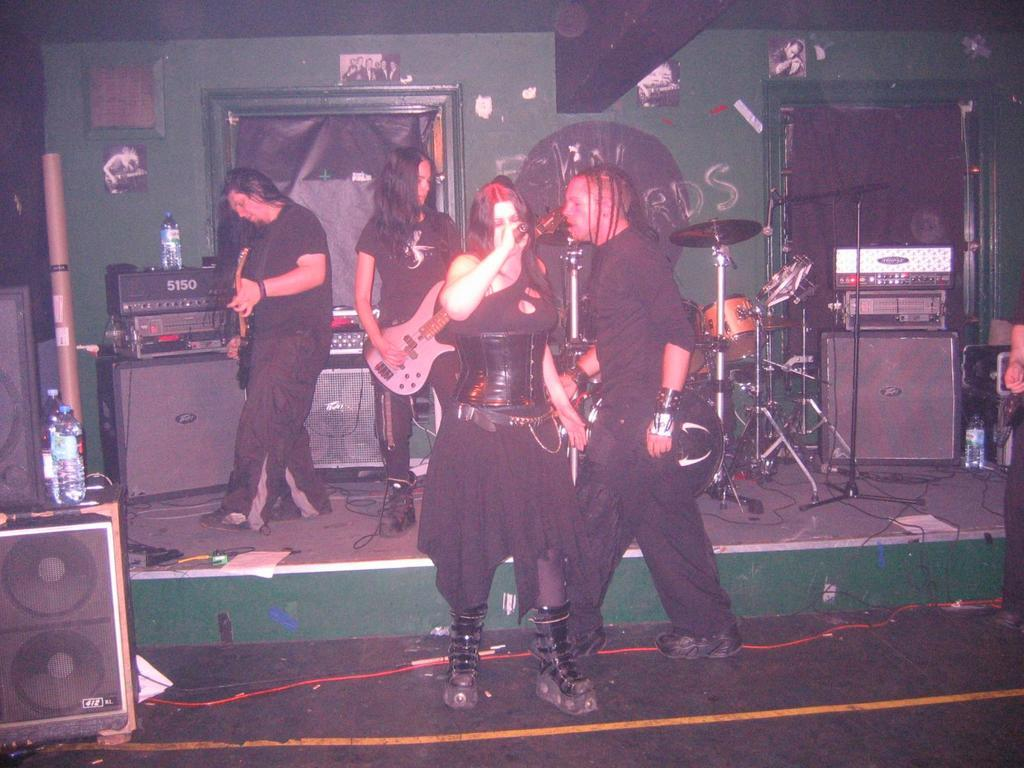What are the people in the image doing? Some people are holding guitars and microphones, which suggests they are musicians or performers. Can you describe any objects in the background of the image? Yes, there are speakers and a drum set in the background of the image. What might be used to amplify sound during a performance? The speakers in the background of the image might be used to amplify sound during a performance. What type of teeth does the girl have in the image? There is no girl present in the image, so it is not possible to determine what type of teeth she might have. 